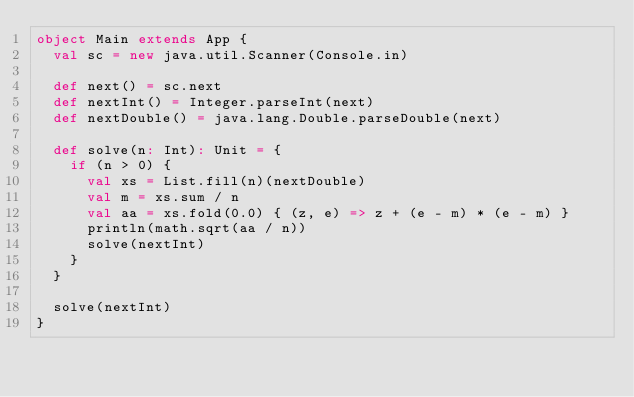<code> <loc_0><loc_0><loc_500><loc_500><_Scala_>object Main extends App {
  val sc = new java.util.Scanner(Console.in)

  def next() = sc.next
  def nextInt() = Integer.parseInt(next)
  def nextDouble() = java.lang.Double.parseDouble(next)

  def solve(n: Int): Unit = {
    if (n > 0) {
      val xs = List.fill(n)(nextDouble)
      val m = xs.sum / n
      val aa = xs.fold(0.0) { (z, e) => z + (e - m) * (e - m) }
      println(math.sqrt(aa / n))
      solve(nextInt)
    }
  }

  solve(nextInt)
}

</code> 